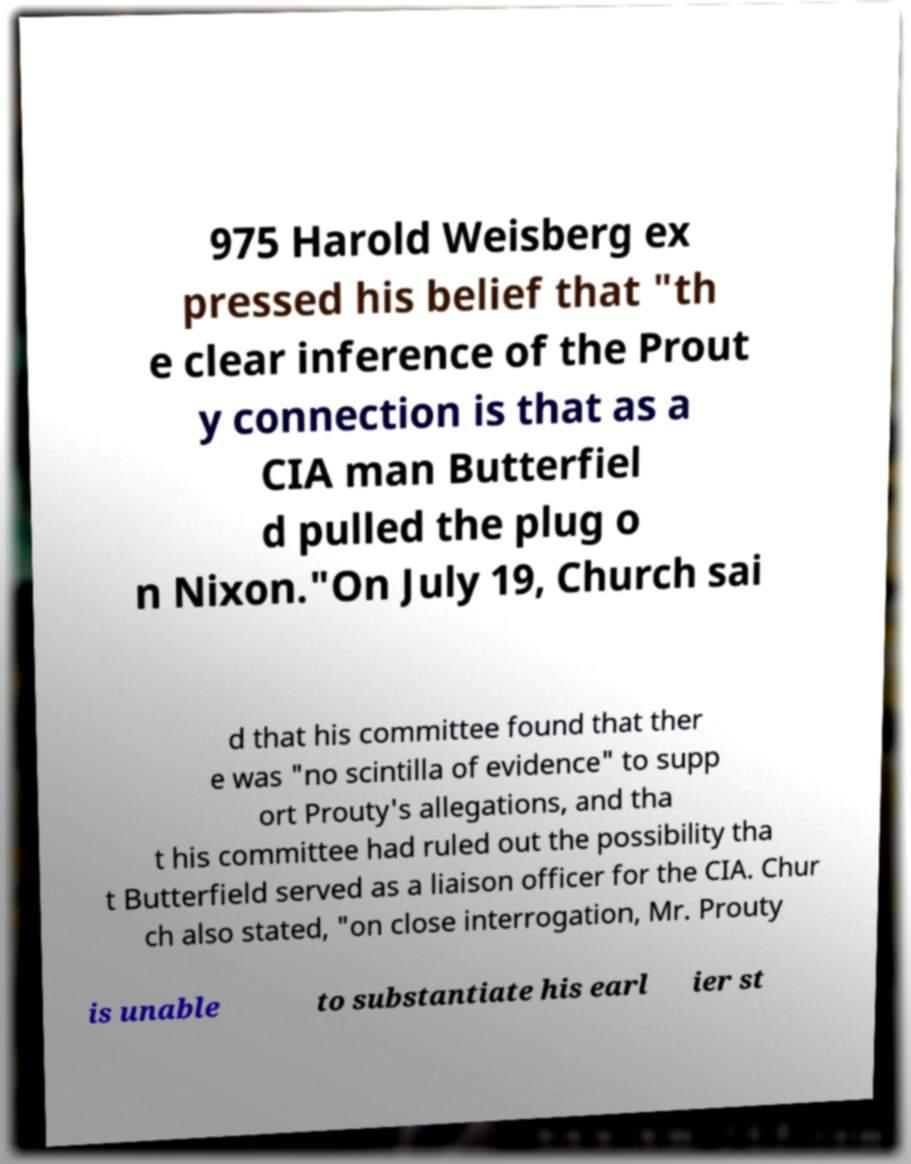Can you accurately transcribe the text from the provided image for me? 975 Harold Weisberg ex pressed his belief that "th e clear inference of the Prout y connection is that as a CIA man Butterfiel d pulled the plug o n Nixon."On July 19, Church sai d that his committee found that ther e was "no scintilla of evidence" to supp ort Prouty's allegations, and tha t his committee had ruled out the possibility tha t Butterfield served as a liaison officer for the CIA. Chur ch also stated, "on close interrogation, Mr. Prouty is unable to substantiate his earl ier st 